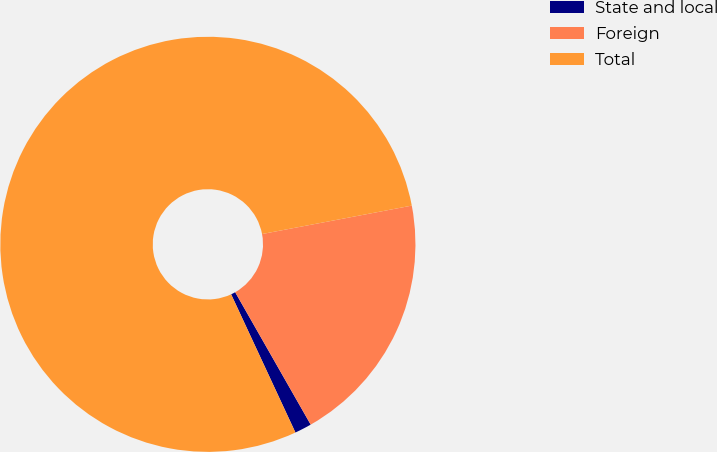Convert chart. <chart><loc_0><loc_0><loc_500><loc_500><pie_chart><fcel>State and local<fcel>Foreign<fcel>Total<nl><fcel>1.32%<fcel>19.74%<fcel>78.95%<nl></chart> 